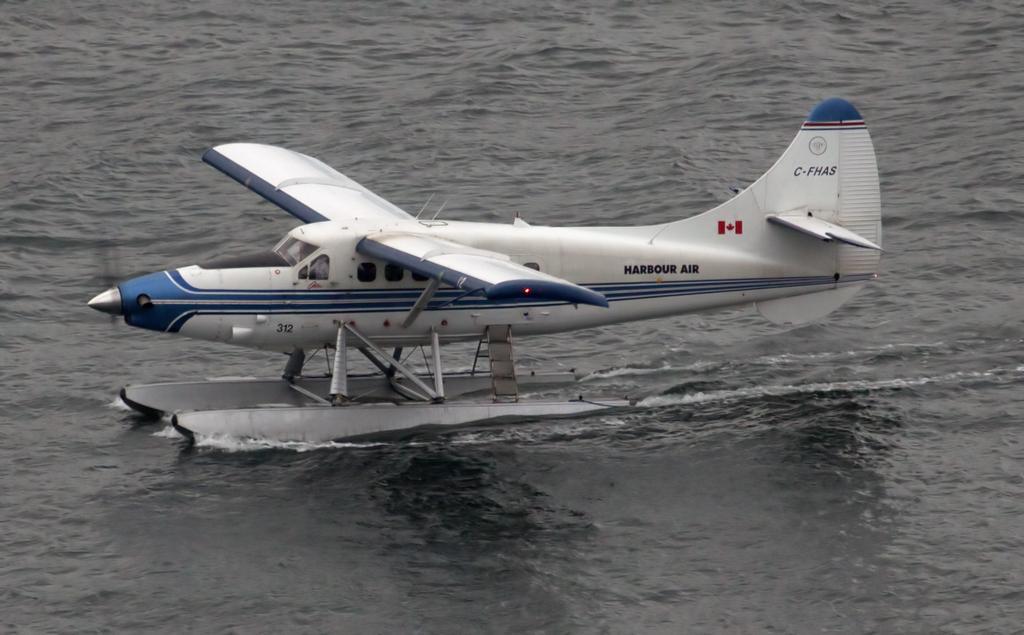In one or two sentences, can you explain what this image depicts? In the picture we can see an aircraft on the water surface. 